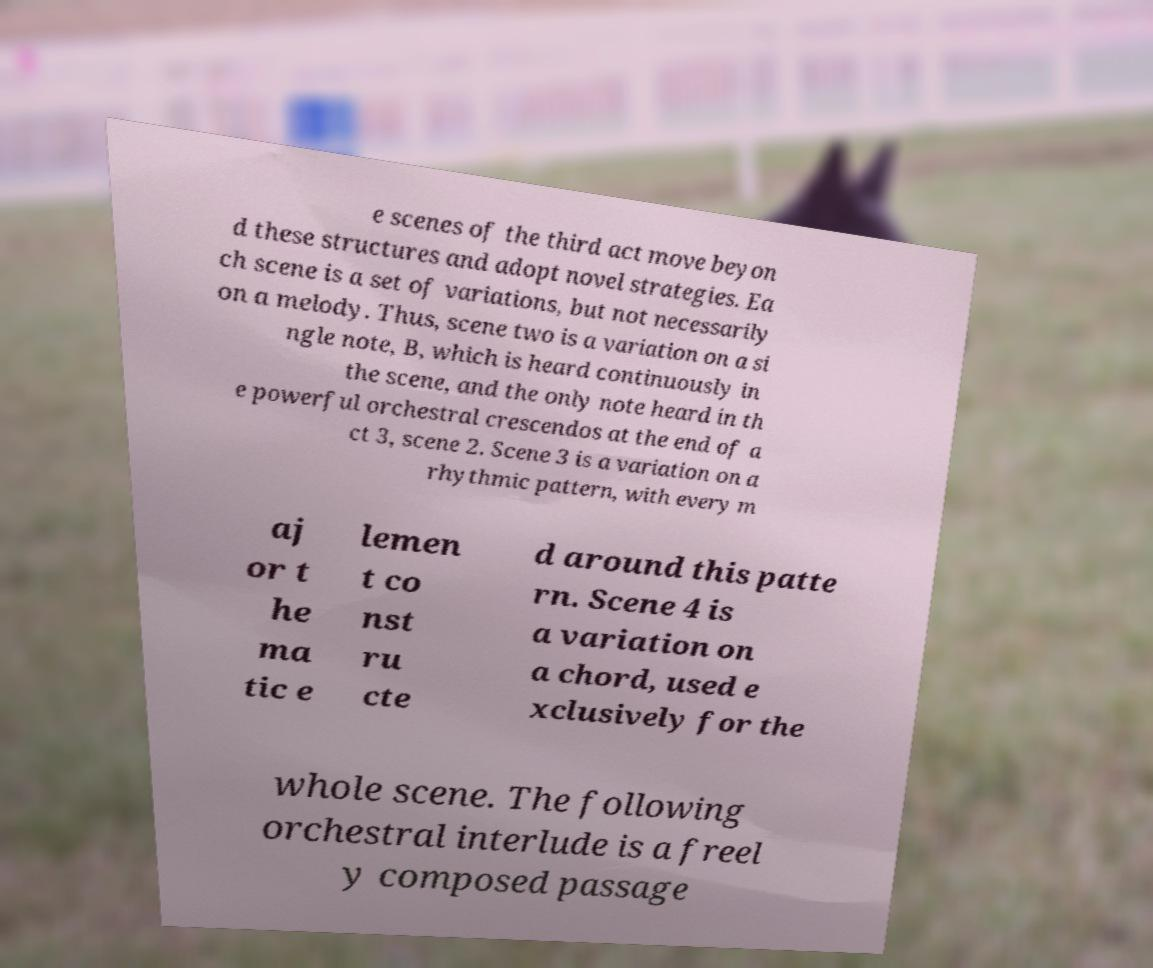Please identify and transcribe the text found in this image. e scenes of the third act move beyon d these structures and adopt novel strategies. Ea ch scene is a set of variations, but not necessarily on a melody. Thus, scene two is a variation on a si ngle note, B, which is heard continuously in the scene, and the only note heard in th e powerful orchestral crescendos at the end of a ct 3, scene 2. Scene 3 is a variation on a rhythmic pattern, with every m aj or t he ma tic e lemen t co nst ru cte d around this patte rn. Scene 4 is a variation on a chord, used e xclusively for the whole scene. The following orchestral interlude is a freel y composed passage 